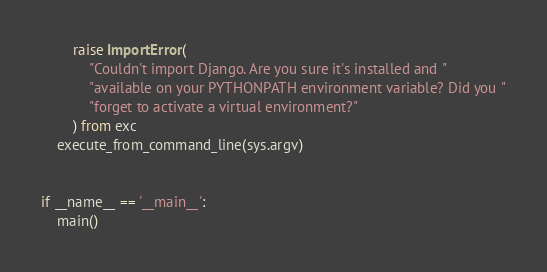<code> <loc_0><loc_0><loc_500><loc_500><_Python_>        raise ImportError(
            "Couldn't import Django. Are you sure it's installed and "
            "available on your PYTHONPATH environment variable? Did you "
            "forget to activate a virtual environment?"
        ) from exc
    execute_from_command_line(sys.argv)


if __name__ == '__main__':
    main()
</code> 